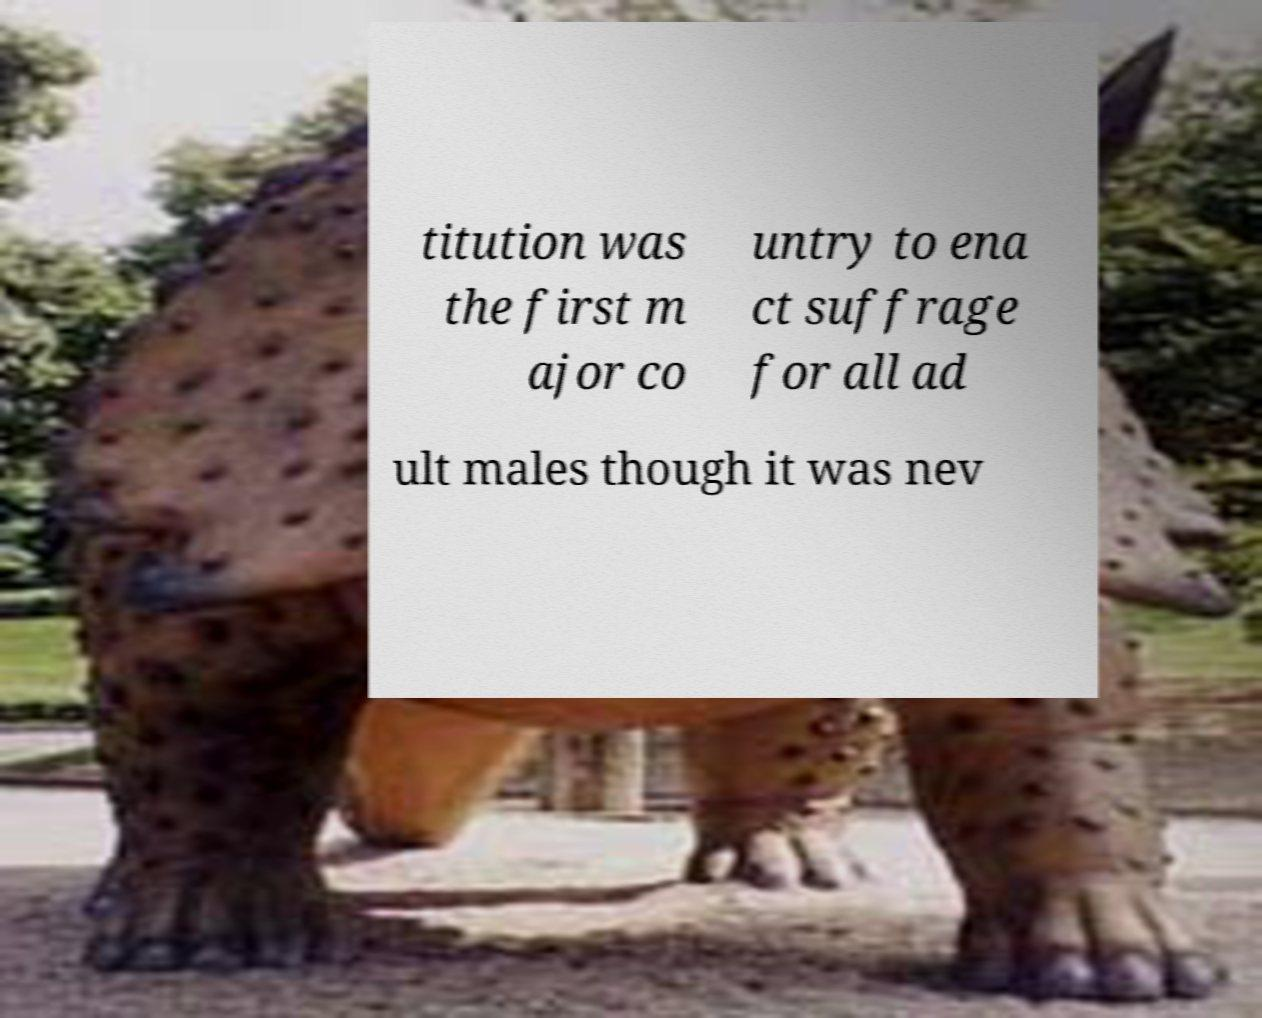Could you extract and type out the text from this image? titution was the first m ajor co untry to ena ct suffrage for all ad ult males though it was nev 